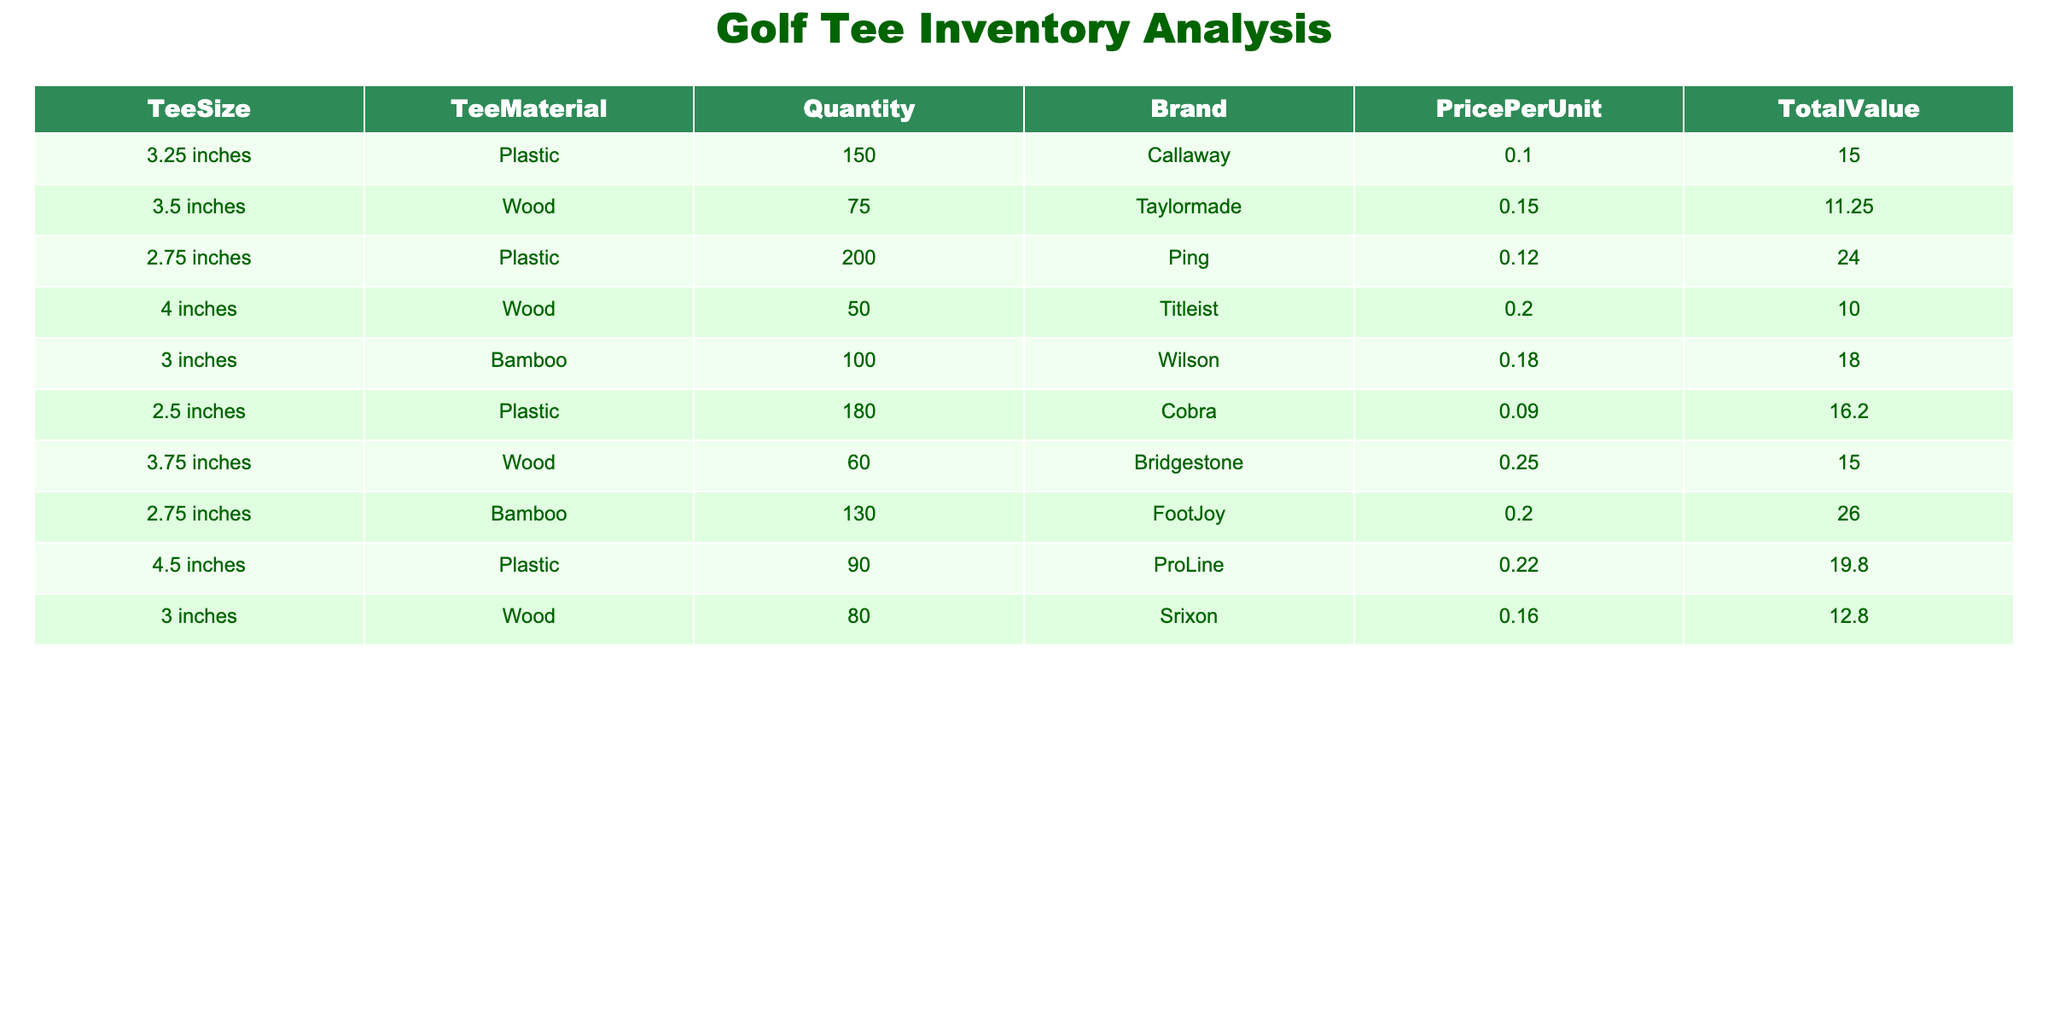What is the total quantity of tees made of plastic? To find the total quantity of plastic tees, we look at each row in the table where the TeeMaterial is "Plastic." The quantities are 150 (3.25 inches), 200 (2.75 inches), and 180 (2.5 inches). Adding these quantities gives us 150 + 200 + 180 = 530.
Answer: 530 What brand has the highest total value in the inventory? We need to compare the TotalValue column for each brand. The total values are: Callaway - 15.00, Taylormade - 11.25, Ping - 24.00, Titleist - 10.00, Wilson - 18.00, Cobra - 16.20, Bridgestone - 15.00, FootJoy - 26.00, ProLine - 19.80, and Srixon - 12.80. FootJoy has the highest total value of 26.00.
Answer: FootJoy How many more bamboo tees are there compared to wood tees? First, we sum the quantity of bamboo tees: 100 (3 inches) + 130 (2.75 inches) = 230. Then, we sum the quantity of wood tees: 75 (3.5 inches) + 50 (4 inches) + 60 (3.75 inches) + 80 (3 inches) = 265. The difference is 230 - 265 = -35, indicating there are 35 more wood tees than bamboo tees.
Answer: 35 Is the price per unit for the 4.5-inch plastic tees higher than the average price per unit for all tees? The price per unit for the 4.5-inch plastic tees is 0.22. To find the average price per unit, we sum all price per unit values: 0.10 + 0.15 + 0.12 + 0.20 + 0.18 + 0.09 + 0.25 + 0.20 + 0.22 + 0.16 = 1.57. There are 10 price points, so the average price per unit is 1.57/10 = 0.157. Since 0.22 is greater than 0.157, the answer is yes.
Answer: Yes What is the total value of all tees made by Callaway and Cobra combined? The total value of Callaway is 15.00 and Cobra is 16.20. We add these values to get a combined total value of 15.00 + 16.20 = 31.20.
Answer: 31.20 